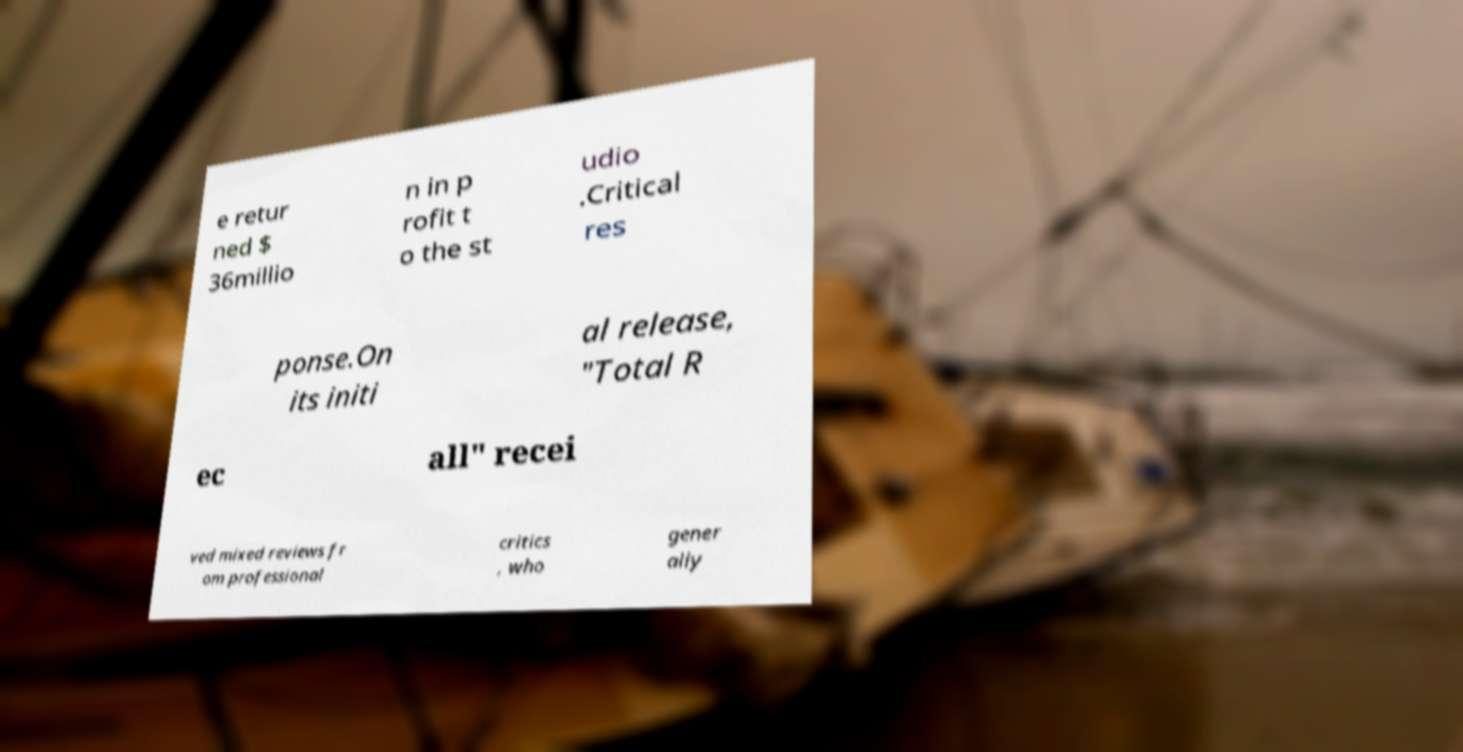Can you read and provide the text displayed in the image?This photo seems to have some interesting text. Can you extract and type it out for me? e retur ned $ 36millio n in p rofit t o the st udio .Critical res ponse.On its initi al release, "Total R ec all" recei ved mixed reviews fr om professional critics , who gener ally 